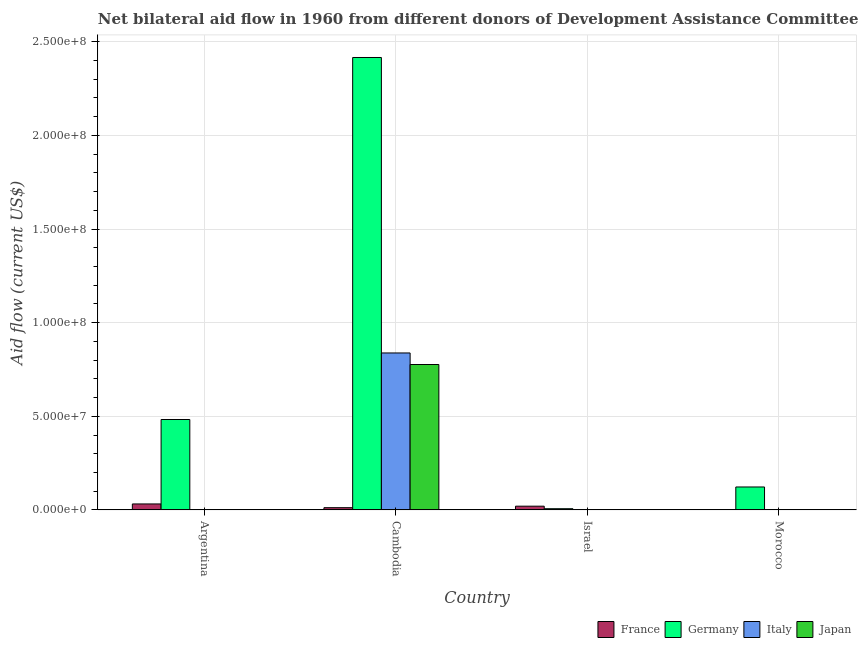How many different coloured bars are there?
Provide a short and direct response. 4. Are the number of bars per tick equal to the number of legend labels?
Your answer should be very brief. No. How many bars are there on the 1st tick from the left?
Offer a very short reply. 2. In how many cases, is the number of bars for a given country not equal to the number of legend labels?
Offer a very short reply. 2. Across all countries, what is the maximum amount of aid given by france?
Make the answer very short. 3.20e+06. Across all countries, what is the minimum amount of aid given by france?
Offer a terse response. 0. In which country was the amount of aid given by germany maximum?
Ensure brevity in your answer.  Cambodia. What is the total amount of aid given by germany in the graph?
Provide a succinct answer. 3.03e+08. What is the difference between the amount of aid given by france in Argentina and that in Israel?
Your answer should be very brief. 1.20e+06. What is the difference between the amount of aid given by italy in Argentina and the amount of aid given by germany in Israel?
Your answer should be very brief. -6.50e+05. What is the average amount of aid given by france per country?
Your answer should be very brief. 1.60e+06. What is the difference between the amount of aid given by japan and amount of aid given by germany in Israel?
Your answer should be compact. -6.40e+05. What is the ratio of the amount of aid given by france in Cambodia to that in Israel?
Offer a terse response. 0.6. Is the amount of aid given by germany in Argentina less than that in Israel?
Your answer should be compact. No. What is the difference between the highest and the second highest amount of aid given by germany?
Offer a terse response. 1.93e+08. What is the difference between the highest and the lowest amount of aid given by germany?
Your answer should be very brief. 2.41e+08. How many bars are there?
Make the answer very short. 11. What is the difference between two consecutive major ticks on the Y-axis?
Ensure brevity in your answer.  5.00e+07. Are the values on the major ticks of Y-axis written in scientific E-notation?
Your answer should be compact. Yes. Where does the legend appear in the graph?
Ensure brevity in your answer.  Bottom right. What is the title of the graph?
Give a very brief answer. Net bilateral aid flow in 1960 from different donors of Development Assistance Committee. Does "Natural Gas" appear as one of the legend labels in the graph?
Offer a terse response. No. What is the label or title of the X-axis?
Offer a terse response. Country. What is the label or title of the Y-axis?
Offer a very short reply. Aid flow (current US$). What is the Aid flow (current US$) of France in Argentina?
Offer a very short reply. 3.20e+06. What is the Aid flow (current US$) in Germany in Argentina?
Make the answer very short. 4.83e+07. What is the Aid flow (current US$) of Italy in Argentina?
Make the answer very short. 0. What is the Aid flow (current US$) in Japan in Argentina?
Offer a terse response. 0. What is the Aid flow (current US$) in France in Cambodia?
Provide a succinct answer. 1.20e+06. What is the Aid flow (current US$) of Germany in Cambodia?
Make the answer very short. 2.42e+08. What is the Aid flow (current US$) of Italy in Cambodia?
Provide a succinct answer. 8.38e+07. What is the Aid flow (current US$) of Japan in Cambodia?
Keep it short and to the point. 7.77e+07. What is the Aid flow (current US$) in Germany in Israel?
Keep it short and to the point. 6.50e+05. What is the Aid flow (current US$) of Japan in Israel?
Ensure brevity in your answer.  10000. What is the Aid flow (current US$) in Germany in Morocco?
Your response must be concise. 1.23e+07. What is the Aid flow (current US$) in Italy in Morocco?
Ensure brevity in your answer.  0. Across all countries, what is the maximum Aid flow (current US$) of France?
Offer a terse response. 3.20e+06. Across all countries, what is the maximum Aid flow (current US$) of Germany?
Keep it short and to the point. 2.42e+08. Across all countries, what is the maximum Aid flow (current US$) in Italy?
Give a very brief answer. 8.38e+07. Across all countries, what is the maximum Aid flow (current US$) of Japan?
Give a very brief answer. 7.77e+07. Across all countries, what is the minimum Aid flow (current US$) of Germany?
Ensure brevity in your answer.  6.50e+05. What is the total Aid flow (current US$) in France in the graph?
Your answer should be very brief. 6.40e+06. What is the total Aid flow (current US$) of Germany in the graph?
Your answer should be very brief. 3.03e+08. What is the total Aid flow (current US$) of Italy in the graph?
Give a very brief answer. 8.38e+07. What is the total Aid flow (current US$) of Japan in the graph?
Your response must be concise. 7.77e+07. What is the difference between the Aid flow (current US$) in Germany in Argentina and that in Cambodia?
Ensure brevity in your answer.  -1.93e+08. What is the difference between the Aid flow (current US$) in France in Argentina and that in Israel?
Provide a short and direct response. 1.20e+06. What is the difference between the Aid flow (current US$) of Germany in Argentina and that in Israel?
Your response must be concise. 4.76e+07. What is the difference between the Aid flow (current US$) of Germany in Argentina and that in Morocco?
Offer a terse response. 3.60e+07. What is the difference between the Aid flow (current US$) of France in Cambodia and that in Israel?
Provide a succinct answer. -8.00e+05. What is the difference between the Aid flow (current US$) of Germany in Cambodia and that in Israel?
Your answer should be compact. 2.41e+08. What is the difference between the Aid flow (current US$) in Italy in Cambodia and that in Israel?
Your answer should be very brief. 8.38e+07. What is the difference between the Aid flow (current US$) of Japan in Cambodia and that in Israel?
Provide a succinct answer. 7.76e+07. What is the difference between the Aid flow (current US$) in Germany in Cambodia and that in Morocco?
Ensure brevity in your answer.  2.29e+08. What is the difference between the Aid flow (current US$) in Germany in Israel and that in Morocco?
Your answer should be very brief. -1.16e+07. What is the difference between the Aid flow (current US$) in France in Argentina and the Aid flow (current US$) in Germany in Cambodia?
Your answer should be compact. -2.38e+08. What is the difference between the Aid flow (current US$) in France in Argentina and the Aid flow (current US$) in Italy in Cambodia?
Your answer should be compact. -8.06e+07. What is the difference between the Aid flow (current US$) in France in Argentina and the Aid flow (current US$) in Japan in Cambodia?
Provide a succinct answer. -7.45e+07. What is the difference between the Aid flow (current US$) of Germany in Argentina and the Aid flow (current US$) of Italy in Cambodia?
Keep it short and to the point. -3.55e+07. What is the difference between the Aid flow (current US$) of Germany in Argentina and the Aid flow (current US$) of Japan in Cambodia?
Offer a very short reply. -2.94e+07. What is the difference between the Aid flow (current US$) in France in Argentina and the Aid flow (current US$) in Germany in Israel?
Your answer should be very brief. 2.55e+06. What is the difference between the Aid flow (current US$) of France in Argentina and the Aid flow (current US$) of Italy in Israel?
Your answer should be compact. 3.19e+06. What is the difference between the Aid flow (current US$) of France in Argentina and the Aid flow (current US$) of Japan in Israel?
Your answer should be compact. 3.19e+06. What is the difference between the Aid flow (current US$) in Germany in Argentina and the Aid flow (current US$) in Italy in Israel?
Offer a very short reply. 4.83e+07. What is the difference between the Aid flow (current US$) of Germany in Argentina and the Aid flow (current US$) of Japan in Israel?
Provide a succinct answer. 4.83e+07. What is the difference between the Aid flow (current US$) of France in Argentina and the Aid flow (current US$) of Germany in Morocco?
Give a very brief answer. -9.06e+06. What is the difference between the Aid flow (current US$) of France in Cambodia and the Aid flow (current US$) of Germany in Israel?
Your answer should be compact. 5.50e+05. What is the difference between the Aid flow (current US$) of France in Cambodia and the Aid flow (current US$) of Italy in Israel?
Give a very brief answer. 1.19e+06. What is the difference between the Aid flow (current US$) in France in Cambodia and the Aid flow (current US$) in Japan in Israel?
Ensure brevity in your answer.  1.19e+06. What is the difference between the Aid flow (current US$) in Germany in Cambodia and the Aid flow (current US$) in Italy in Israel?
Your response must be concise. 2.42e+08. What is the difference between the Aid flow (current US$) in Germany in Cambodia and the Aid flow (current US$) in Japan in Israel?
Provide a short and direct response. 2.42e+08. What is the difference between the Aid flow (current US$) of Italy in Cambodia and the Aid flow (current US$) of Japan in Israel?
Your response must be concise. 8.38e+07. What is the difference between the Aid flow (current US$) in France in Cambodia and the Aid flow (current US$) in Germany in Morocco?
Your response must be concise. -1.11e+07. What is the difference between the Aid flow (current US$) of France in Israel and the Aid flow (current US$) of Germany in Morocco?
Provide a short and direct response. -1.03e+07. What is the average Aid flow (current US$) of France per country?
Your answer should be compact. 1.60e+06. What is the average Aid flow (current US$) in Germany per country?
Keep it short and to the point. 7.57e+07. What is the average Aid flow (current US$) in Italy per country?
Provide a succinct answer. 2.10e+07. What is the average Aid flow (current US$) in Japan per country?
Give a very brief answer. 1.94e+07. What is the difference between the Aid flow (current US$) of France and Aid flow (current US$) of Germany in Argentina?
Offer a terse response. -4.51e+07. What is the difference between the Aid flow (current US$) in France and Aid flow (current US$) in Germany in Cambodia?
Your answer should be very brief. -2.40e+08. What is the difference between the Aid flow (current US$) of France and Aid flow (current US$) of Italy in Cambodia?
Keep it short and to the point. -8.26e+07. What is the difference between the Aid flow (current US$) in France and Aid flow (current US$) in Japan in Cambodia?
Offer a terse response. -7.65e+07. What is the difference between the Aid flow (current US$) of Germany and Aid flow (current US$) of Italy in Cambodia?
Provide a succinct answer. 1.58e+08. What is the difference between the Aid flow (current US$) of Germany and Aid flow (current US$) of Japan in Cambodia?
Your response must be concise. 1.64e+08. What is the difference between the Aid flow (current US$) in Italy and Aid flow (current US$) in Japan in Cambodia?
Your answer should be very brief. 6.17e+06. What is the difference between the Aid flow (current US$) of France and Aid flow (current US$) of Germany in Israel?
Ensure brevity in your answer.  1.35e+06. What is the difference between the Aid flow (current US$) in France and Aid flow (current US$) in Italy in Israel?
Give a very brief answer. 1.99e+06. What is the difference between the Aid flow (current US$) in France and Aid flow (current US$) in Japan in Israel?
Ensure brevity in your answer.  1.99e+06. What is the difference between the Aid flow (current US$) of Germany and Aid flow (current US$) of Italy in Israel?
Your answer should be compact. 6.40e+05. What is the difference between the Aid flow (current US$) of Germany and Aid flow (current US$) of Japan in Israel?
Your answer should be compact. 6.40e+05. What is the difference between the Aid flow (current US$) of Italy and Aid flow (current US$) of Japan in Israel?
Your response must be concise. 0. What is the ratio of the Aid flow (current US$) in France in Argentina to that in Cambodia?
Provide a short and direct response. 2.67. What is the ratio of the Aid flow (current US$) of Germany in Argentina to that in Cambodia?
Provide a short and direct response. 0.2. What is the ratio of the Aid flow (current US$) of Germany in Argentina to that in Israel?
Offer a very short reply. 74.29. What is the ratio of the Aid flow (current US$) of Germany in Argentina to that in Morocco?
Your response must be concise. 3.94. What is the ratio of the Aid flow (current US$) of France in Cambodia to that in Israel?
Keep it short and to the point. 0.6. What is the ratio of the Aid flow (current US$) of Germany in Cambodia to that in Israel?
Offer a very short reply. 371.71. What is the ratio of the Aid flow (current US$) in Italy in Cambodia to that in Israel?
Your answer should be compact. 8383. What is the ratio of the Aid flow (current US$) of Japan in Cambodia to that in Israel?
Offer a very short reply. 7766. What is the ratio of the Aid flow (current US$) of Germany in Cambodia to that in Morocco?
Provide a succinct answer. 19.71. What is the ratio of the Aid flow (current US$) of Germany in Israel to that in Morocco?
Your answer should be compact. 0.05. What is the difference between the highest and the second highest Aid flow (current US$) in France?
Provide a short and direct response. 1.20e+06. What is the difference between the highest and the second highest Aid flow (current US$) in Germany?
Your response must be concise. 1.93e+08. What is the difference between the highest and the lowest Aid flow (current US$) of France?
Keep it short and to the point. 3.20e+06. What is the difference between the highest and the lowest Aid flow (current US$) in Germany?
Offer a very short reply. 2.41e+08. What is the difference between the highest and the lowest Aid flow (current US$) of Italy?
Offer a terse response. 8.38e+07. What is the difference between the highest and the lowest Aid flow (current US$) of Japan?
Offer a very short reply. 7.77e+07. 